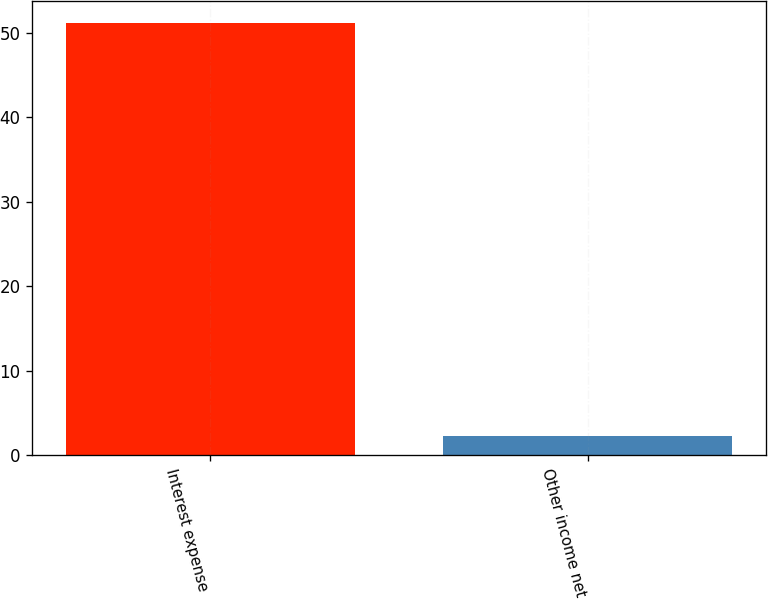<chart> <loc_0><loc_0><loc_500><loc_500><bar_chart><fcel>Interest expense<fcel>Other income net<nl><fcel>51.2<fcel>2.3<nl></chart> 